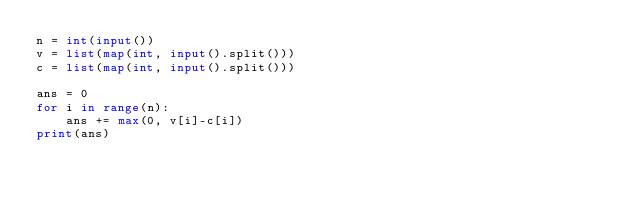<code> <loc_0><loc_0><loc_500><loc_500><_Python_>n = int(input())
v = list(map(int, input().split()))
c = list(map(int, input().split()))

ans = 0
for i in range(n):
    ans += max(0, v[i]-c[i])
print(ans)</code> 